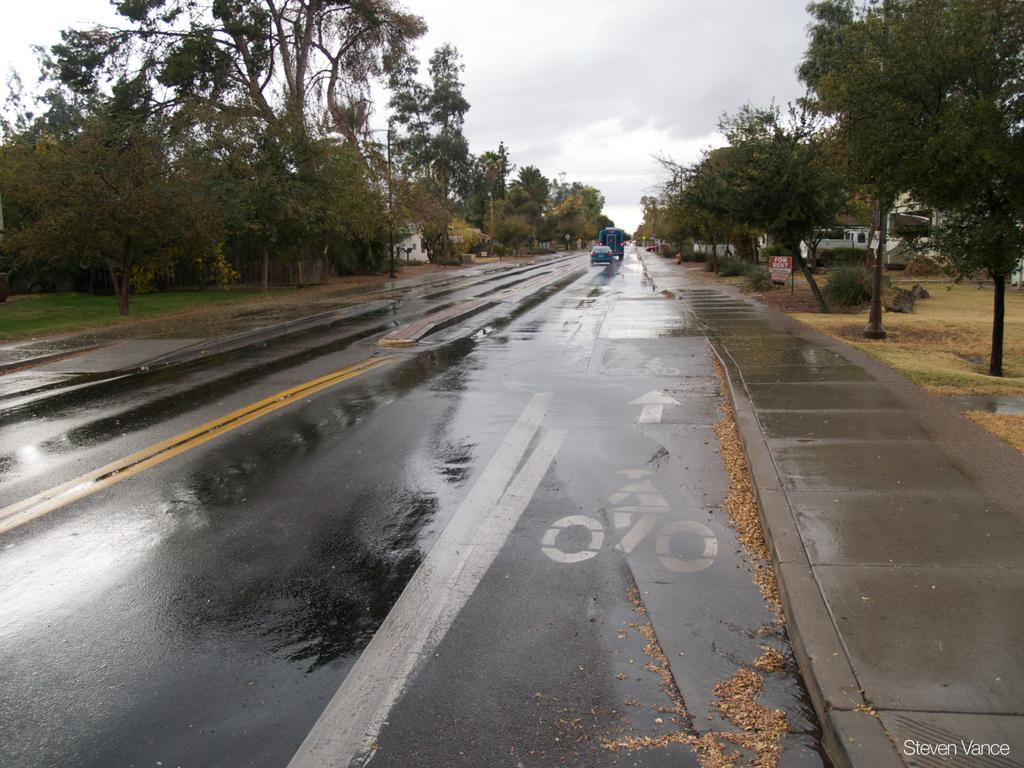What type of vehicles are in the image? There is a car and a truck in the image. Where are the vehicles located? Both vehicles are on the road in the image. What can be seen on the sides of the road? There are trees on both the left and right sides of the image. What is visible in the sky at the top of the image? There are clouds visible in the sky at the top of the image. What type of cracker is being used to create harmony between the pig and the truck in the image? There is no cracker, pig, or any indication of harmony in the image; it only features a car and a truck on the road. 